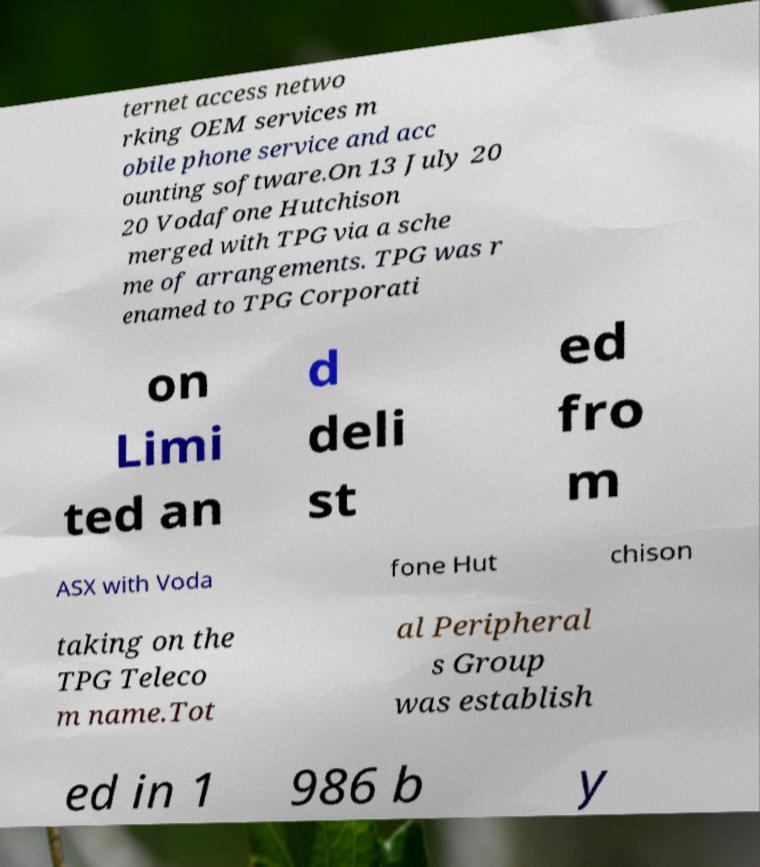I need the written content from this picture converted into text. Can you do that? ternet access netwo rking OEM services m obile phone service and acc ounting software.On 13 July 20 20 Vodafone Hutchison merged with TPG via a sche me of arrangements. TPG was r enamed to TPG Corporati on Limi ted an d deli st ed fro m ASX with Voda fone Hut chison taking on the TPG Teleco m name.Tot al Peripheral s Group was establish ed in 1 986 b y 